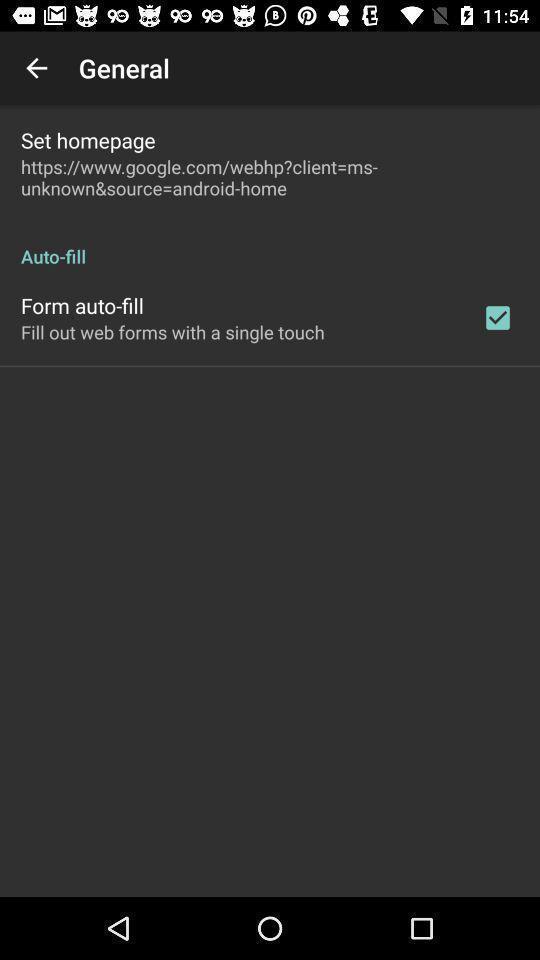Explain what's happening in this screen capture. Screen displaying general options. 